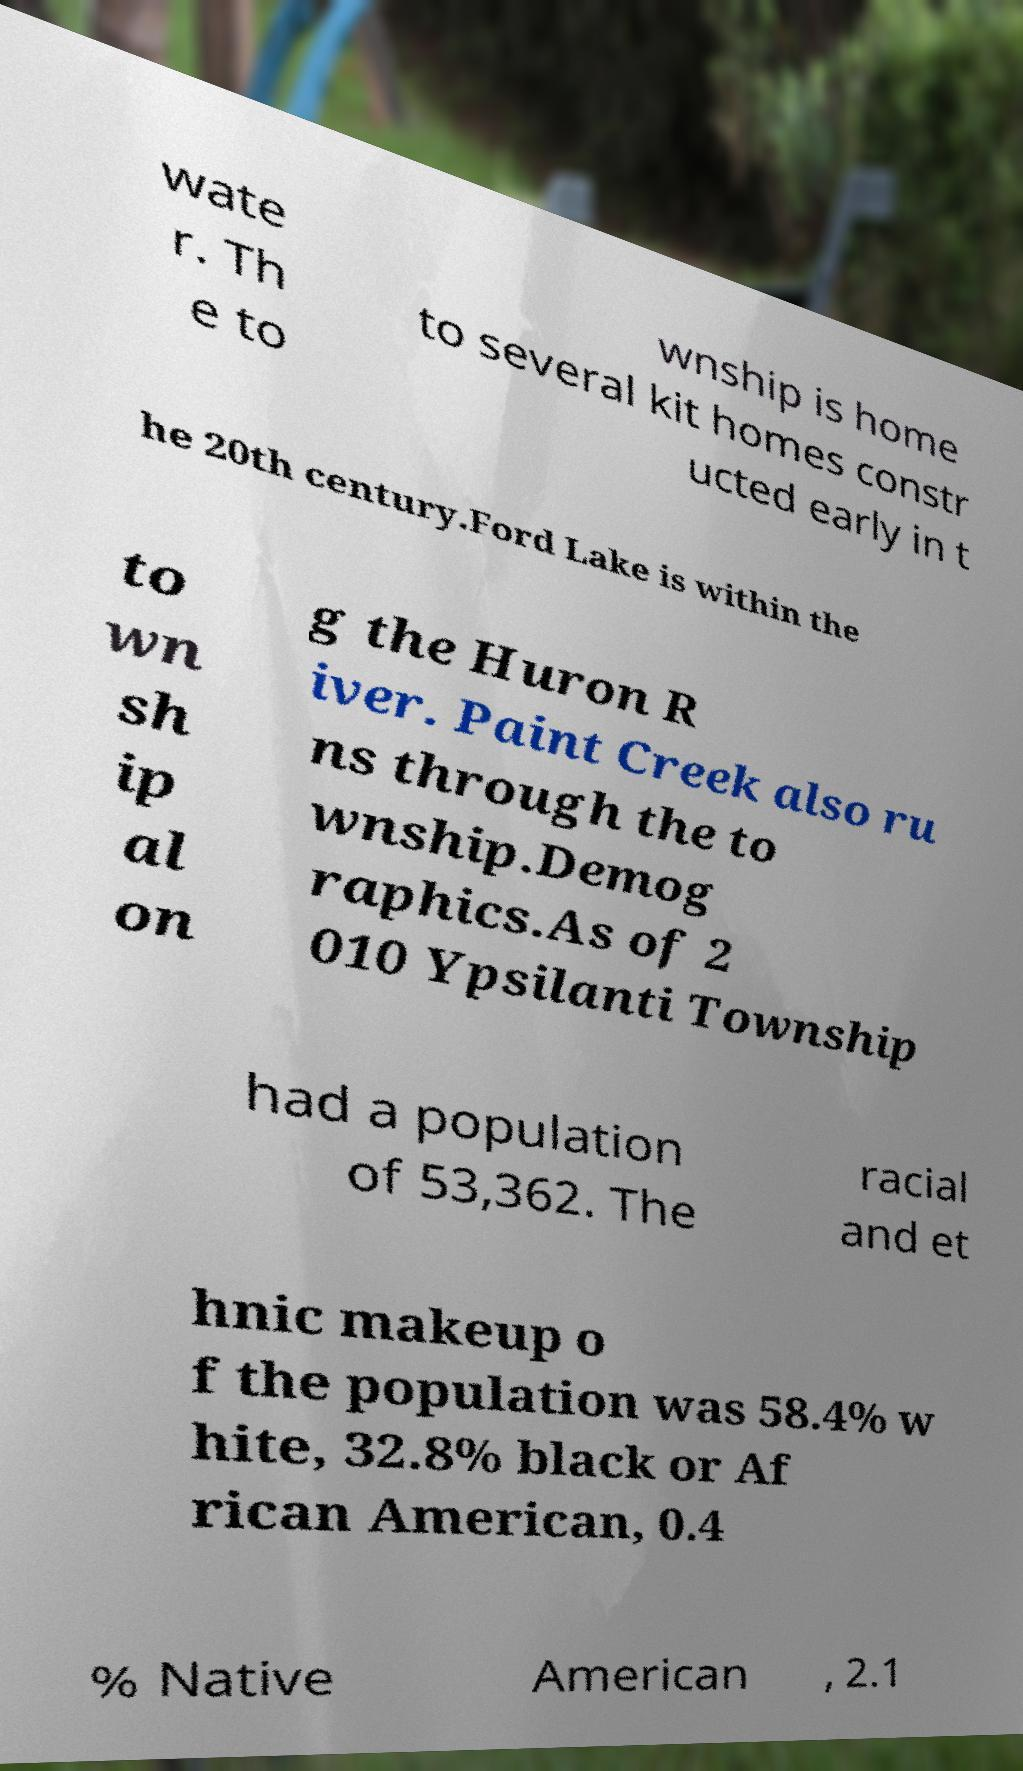There's text embedded in this image that I need extracted. Can you transcribe it verbatim? wate r. Th e to wnship is home to several kit homes constr ucted early in t he 20th century.Ford Lake is within the to wn sh ip al on g the Huron R iver. Paint Creek also ru ns through the to wnship.Demog raphics.As of 2 010 Ypsilanti Township had a population of 53,362. The racial and et hnic makeup o f the population was 58.4% w hite, 32.8% black or Af rican American, 0.4 % Native American , 2.1 